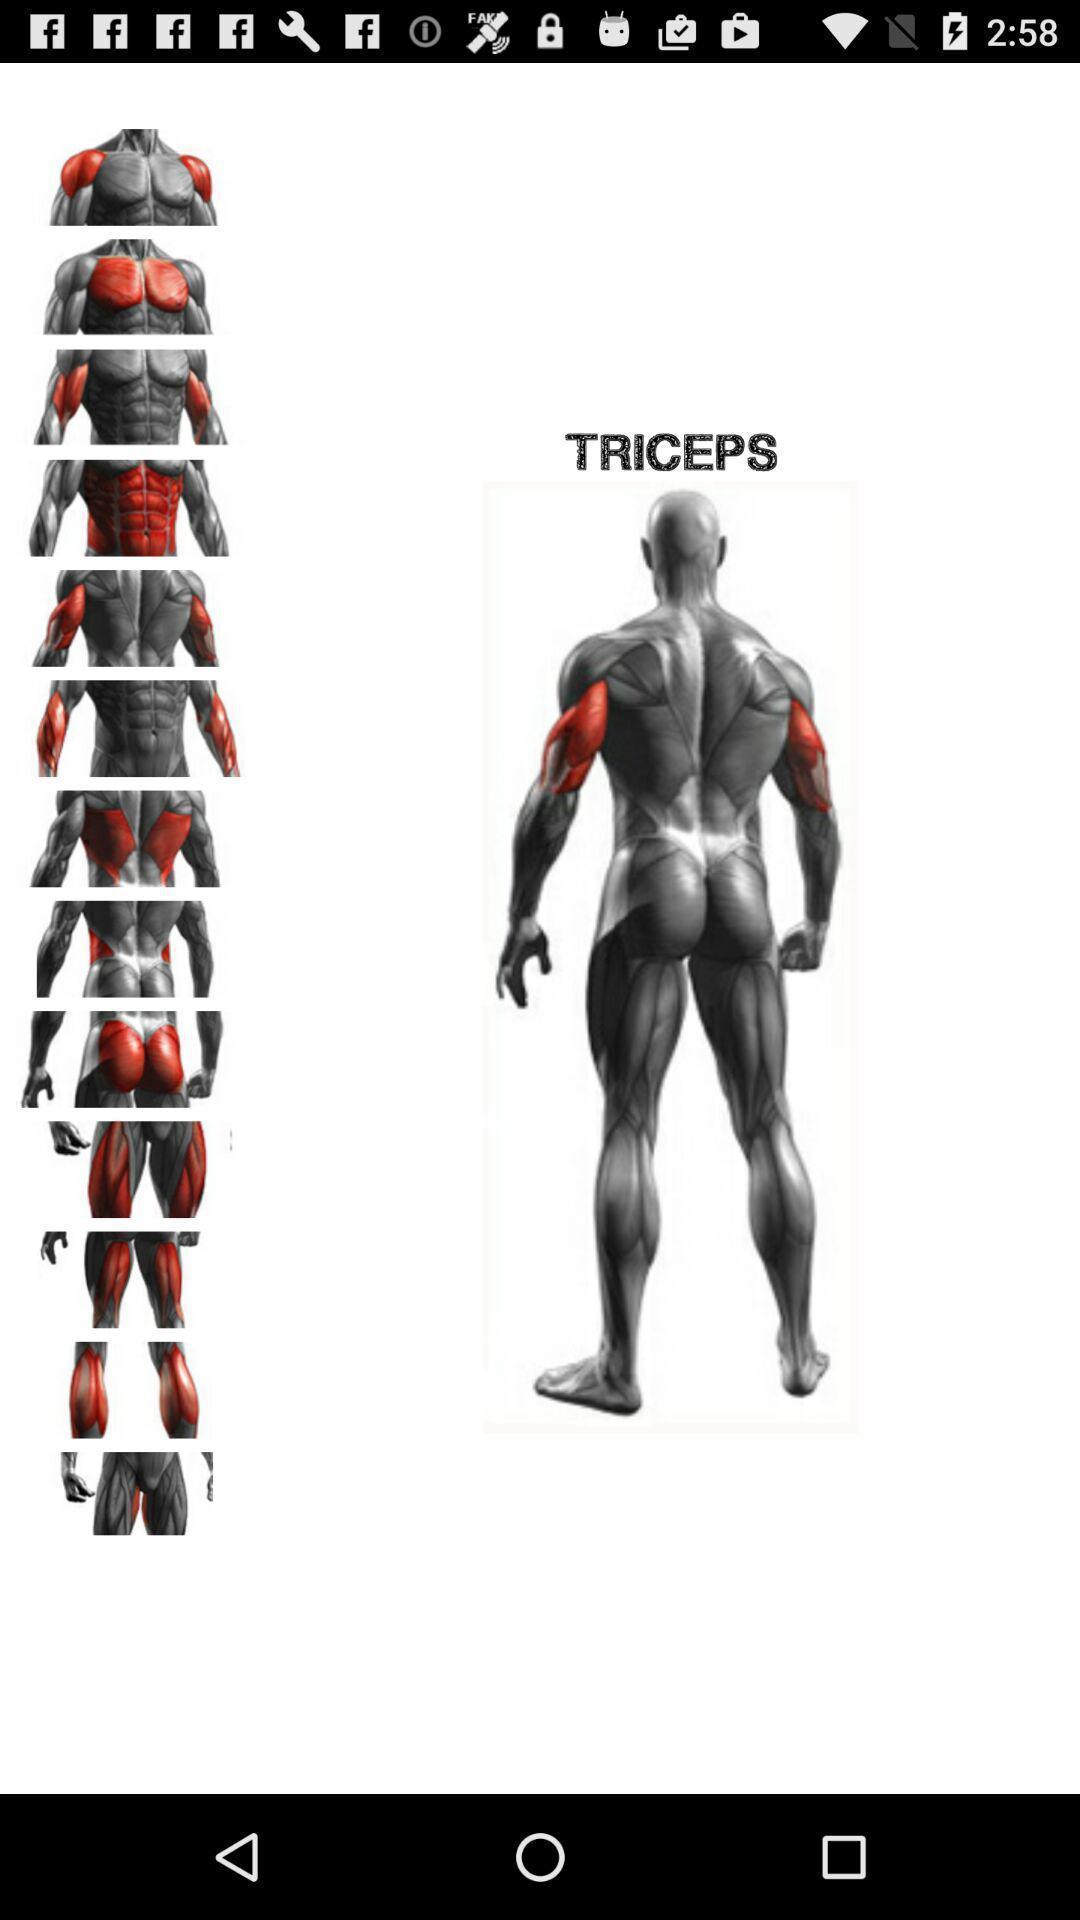Tell me about the visual elements in this screen capture. Screen showing various body muscles for health app. 